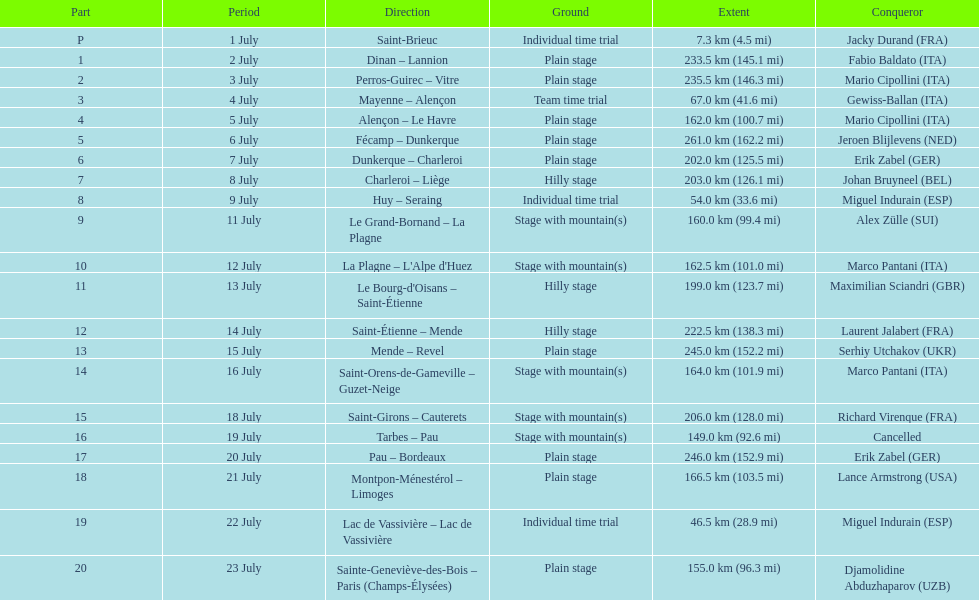After lance armstrong, who took the lead in the 1995 tour de france? Miguel Indurain. 